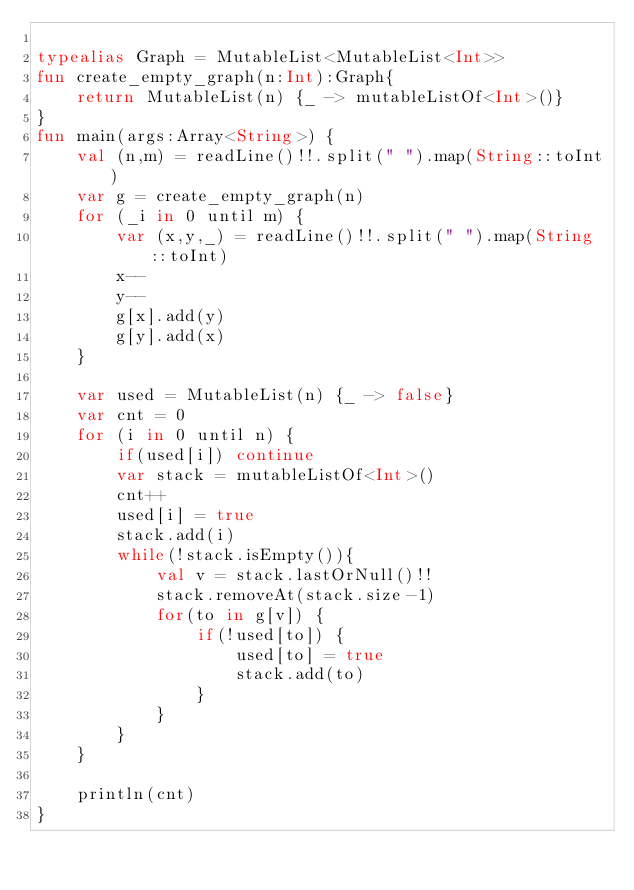Convert code to text. <code><loc_0><loc_0><loc_500><loc_500><_Kotlin_>
typealias Graph = MutableList<MutableList<Int>>
fun create_empty_graph(n:Int):Graph{
    return MutableList(n) {_ -> mutableListOf<Int>()}
}
fun main(args:Array<String>) {
    val (n,m) = readLine()!!.split(" ").map(String::toInt)
    var g = create_empty_graph(n)
    for (_i in 0 until m) {
        var (x,y,_) = readLine()!!.split(" ").map(String::toInt)
        x--
        y--
        g[x].add(y)
        g[y].add(x)
    }

    var used = MutableList(n) {_ -> false}
    var cnt = 0
    for (i in 0 until n) {
        if(used[i]) continue
        var stack = mutableListOf<Int>()
        cnt++
        used[i] = true
        stack.add(i)
        while(!stack.isEmpty()){
            val v = stack.lastOrNull()!!
            stack.removeAt(stack.size-1)
            for(to in g[v]) {
                if(!used[to]) {
                    used[to] = true
                    stack.add(to)
                }
            }
        }
    }

    println(cnt)
}
</code> 